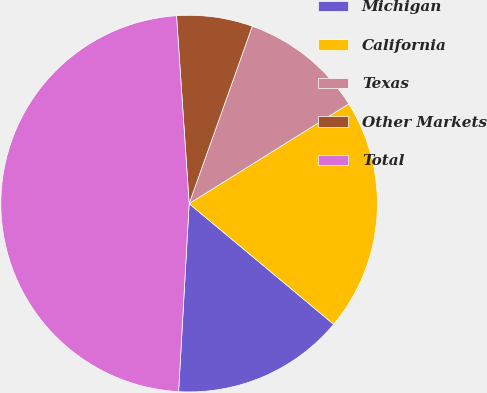<chart> <loc_0><loc_0><loc_500><loc_500><pie_chart><fcel>Michigan<fcel>California<fcel>Texas<fcel>Other Markets<fcel>Total<nl><fcel>14.82%<fcel>19.96%<fcel>10.67%<fcel>6.51%<fcel>48.05%<nl></chart> 